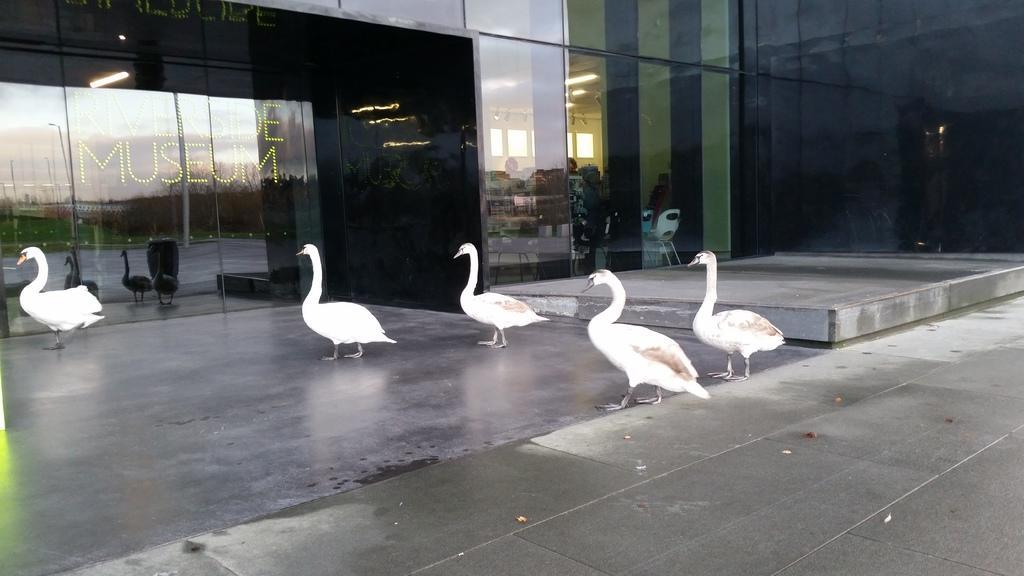Could you give a brief overview of what you see in this image? In this image we can see few birds on the floor, there is a building with text and we can see the reflection of few trees, birds and the sky on the glass of a building, and through the glass we can see chairs, windows, lights to the ceiling and few objects inside the building. 